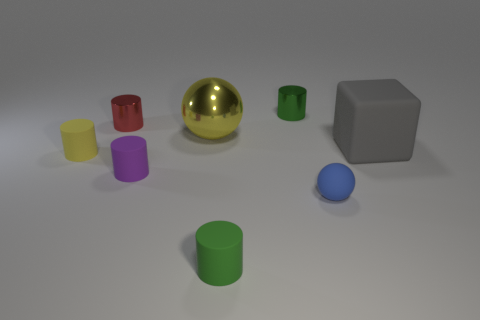There is a tiny rubber thing that is to the right of the rubber object that is in front of the blue matte ball; what number of small purple rubber things are in front of it?
Provide a succinct answer. 0. There is a green matte object that is the same shape as the tiny purple object; what size is it?
Make the answer very short. Small. Are there any other things that have the same size as the green matte cylinder?
Your response must be concise. Yes. Are there fewer cylinders in front of the blue matte thing than small cyan spheres?
Offer a very short reply. No. Is the yellow matte object the same shape as the red object?
Provide a short and direct response. Yes. There is another metallic thing that is the same shape as the tiny red thing; what is its color?
Offer a very short reply. Green. How many big metallic balls are the same color as the large metal object?
Provide a succinct answer. 0. What number of objects are either tiny things that are in front of the small red metal cylinder or red cylinders?
Keep it short and to the point. 5. What is the size of the matte thing behind the yellow rubber cylinder?
Your answer should be compact. Large. Is the number of tiny rubber cylinders less than the number of small brown objects?
Your answer should be compact. No. 